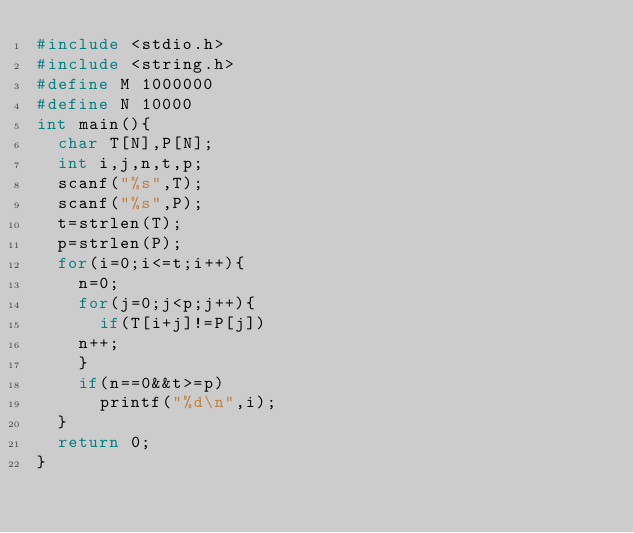Convert code to text. <code><loc_0><loc_0><loc_500><loc_500><_C_>#include <stdio.h>
#include <string.h>
#define M 1000000
#define N 10000
int main(){
  char T[N],P[N];
  int i,j,n,t,p;
  scanf("%s",T);
  scanf("%s",P);
  t=strlen(T);
  p=strlen(P);
  for(i=0;i<=t;i++){
    n=0;
    for(j=0;j<p;j++){
      if(T[i+j]!=P[j])
	n++;
    }
    if(n==0&&t>=p)
      printf("%d\n",i);
  }
  return 0;
}</code> 